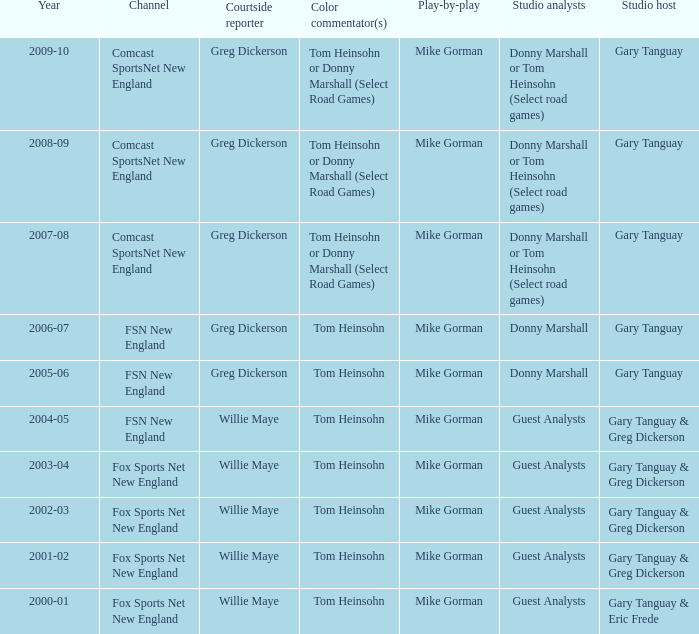Which Color commentator has a Channel of fsn new england, and a Year of 2004-05? Tom Heinsohn. 